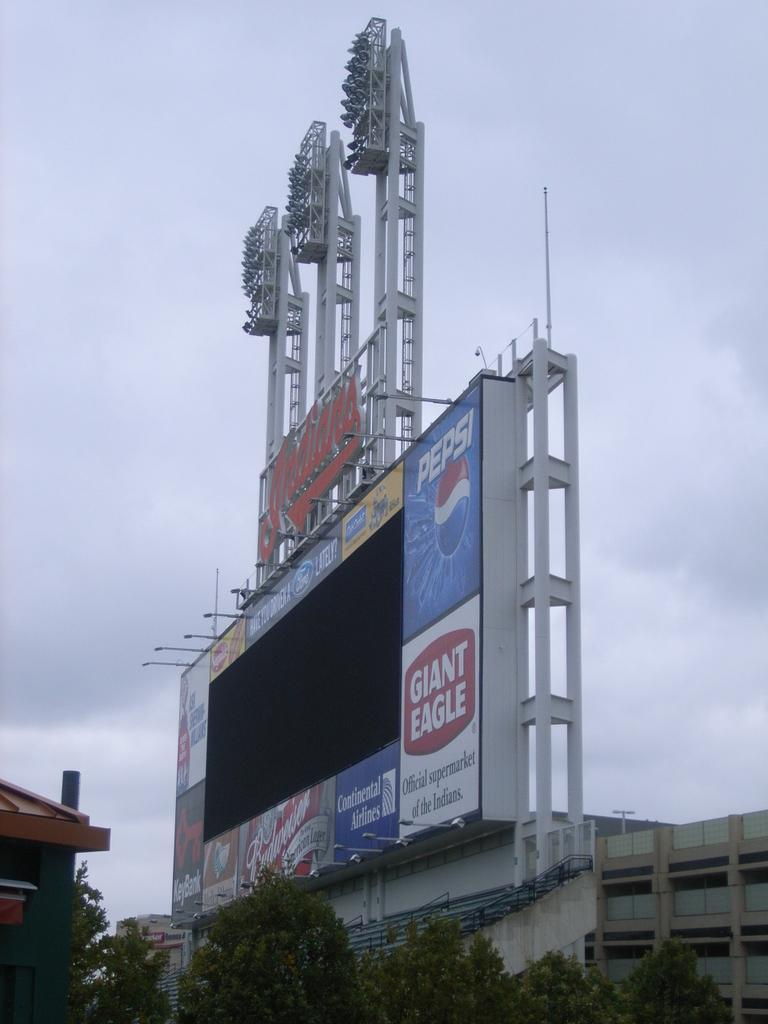What type of structures can be seen in the image? There are buildings in the image. What type of natural elements are present in the image? There are trees in the image. What is the additional feature visible in the image? There is a banner in the image. What is visible at the top of the image? The sky is visible in the image. What type of news can be heard coming from the buildings in the image? There is no indication in the image that any news is being broadcasted or discussed in the buildings. Is there any snow visible in the image? There is no snow present in the image. 